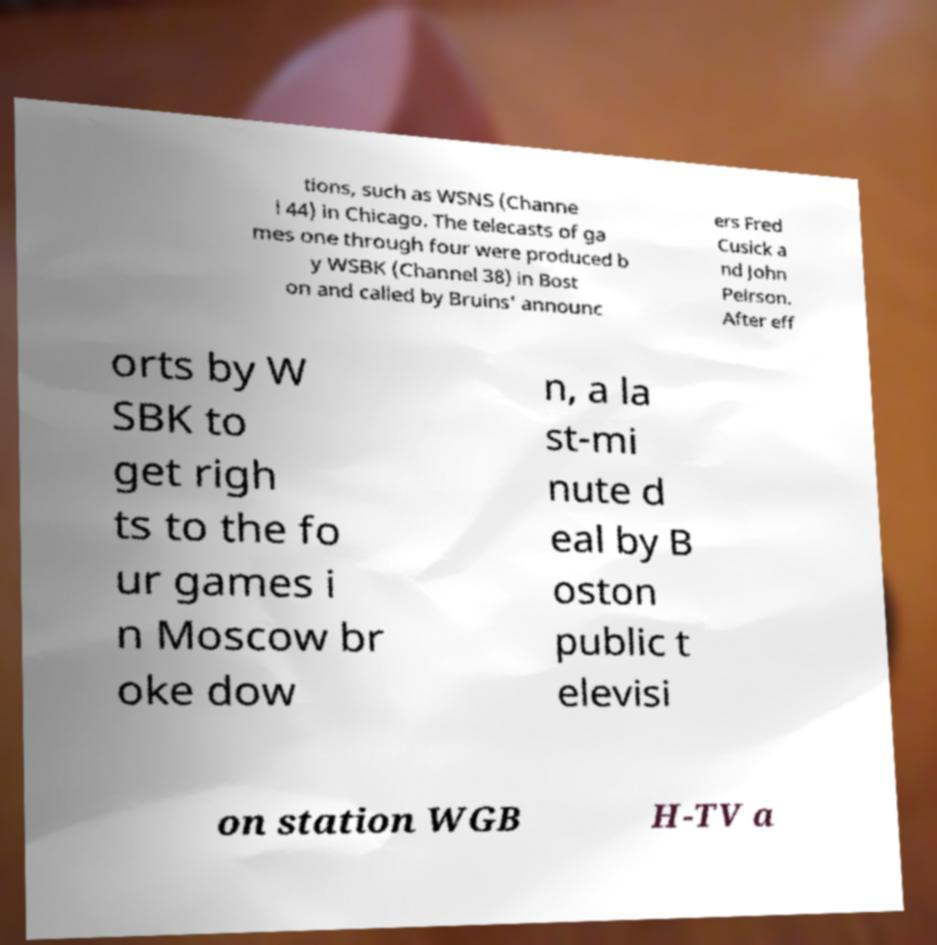For documentation purposes, I need the text within this image transcribed. Could you provide that? tions, such as WSNS (Channe l 44) in Chicago. The telecasts of ga mes one through four were produced b y WSBK (Channel 38) in Bost on and called by Bruins' announc ers Fred Cusick a nd John Peirson. After eff orts by W SBK to get righ ts to the fo ur games i n Moscow br oke dow n, a la st-mi nute d eal by B oston public t elevisi on station WGB H-TV a 